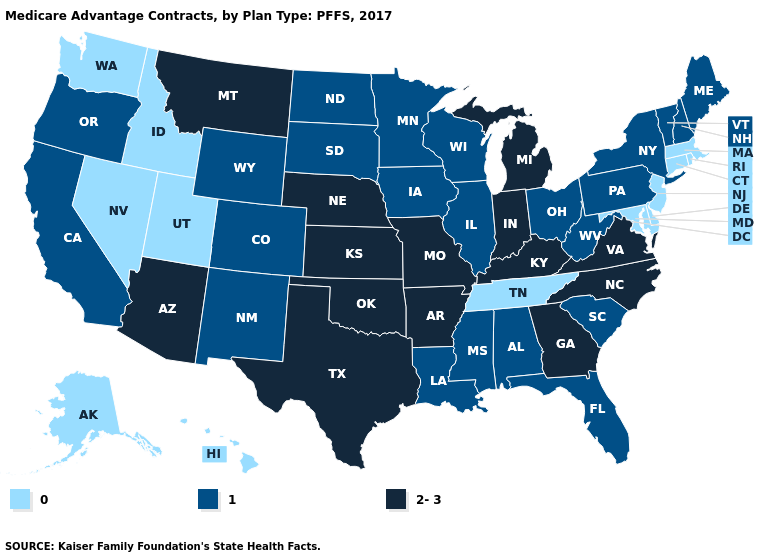What is the lowest value in the USA?
Answer briefly. 0. How many symbols are there in the legend?
Write a very short answer. 3. What is the lowest value in the USA?
Be succinct. 0. What is the value of Louisiana?
Short answer required. 1. Does Arkansas have the lowest value in the USA?
Give a very brief answer. No. How many symbols are there in the legend?
Concise answer only. 3. What is the lowest value in the South?
Quick response, please. 0. Name the states that have a value in the range 1?
Be succinct. Alabama, California, Colorado, Florida, Iowa, Illinois, Louisiana, Maine, Minnesota, Mississippi, North Dakota, New Hampshire, New Mexico, New York, Ohio, Oregon, Pennsylvania, South Carolina, South Dakota, Vermont, Wisconsin, West Virginia, Wyoming. Name the states that have a value in the range 2-3?
Concise answer only. Arkansas, Arizona, Georgia, Indiana, Kansas, Kentucky, Michigan, Missouri, Montana, North Carolina, Nebraska, Oklahoma, Texas, Virginia. What is the lowest value in states that border Tennessee?
Concise answer only. 1. What is the value of Hawaii?
Short answer required. 0. Name the states that have a value in the range 2-3?
Short answer required. Arkansas, Arizona, Georgia, Indiana, Kansas, Kentucky, Michigan, Missouri, Montana, North Carolina, Nebraska, Oklahoma, Texas, Virginia. What is the value of New Mexico?
Answer briefly. 1. 